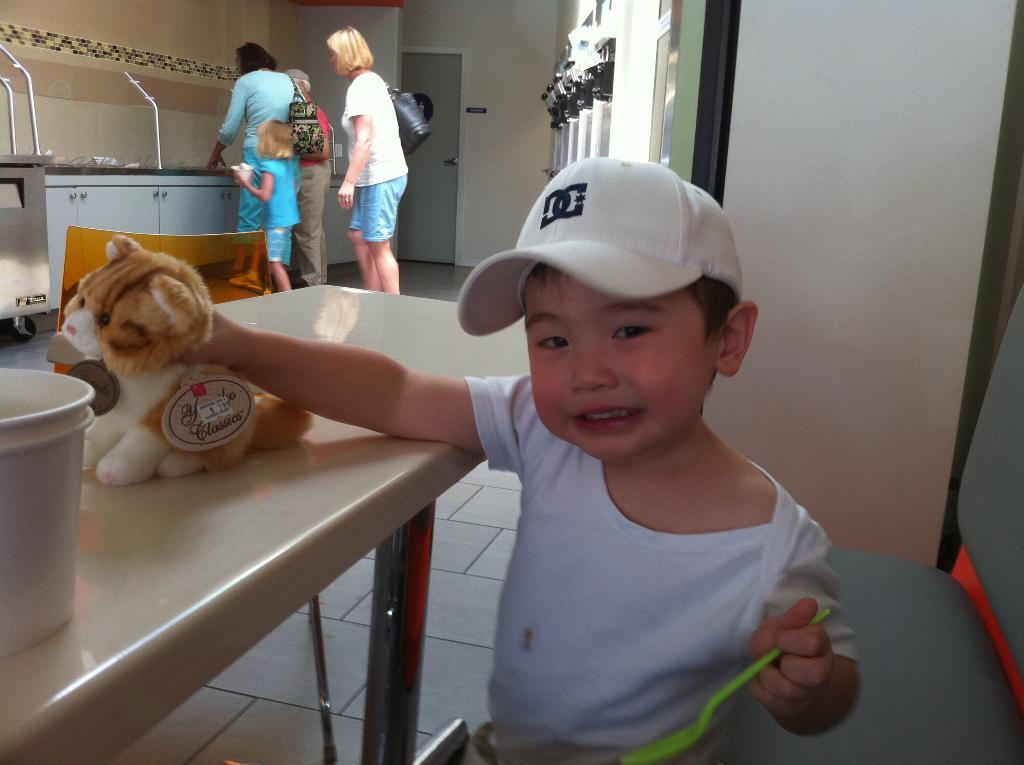What is the main subject of the image? The main subject of the image is a kid. What is the kid wearing? The kid is wearing a white shirt. What is the kid holding in his right hand? The kid is holding a toy in his right hand. Where is the toy located? The toy is on a table. Can you describe the people behind the kid? There are people behind the kid, but their specific features or actions are not mentioned in the facts. What type of plate is the kid using to express his anger in the image? There is no plate or expression of anger present in the image. 